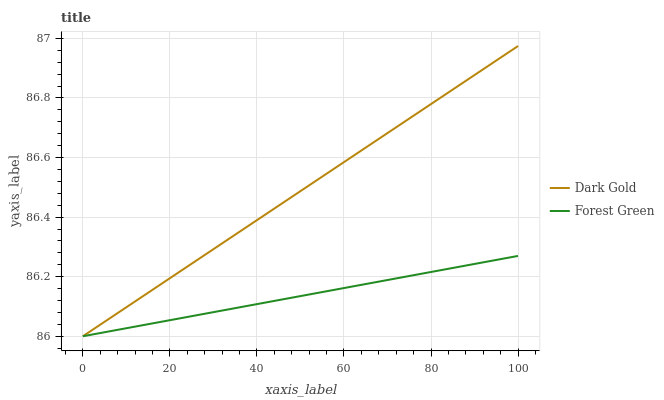Does Forest Green have the minimum area under the curve?
Answer yes or no. Yes. Does Dark Gold have the maximum area under the curve?
Answer yes or no. Yes. Does Dark Gold have the minimum area under the curve?
Answer yes or no. No. Is Dark Gold the smoothest?
Answer yes or no. Yes. Is Forest Green the roughest?
Answer yes or no. Yes. Is Dark Gold the roughest?
Answer yes or no. No. Does Dark Gold have the highest value?
Answer yes or no. Yes. 